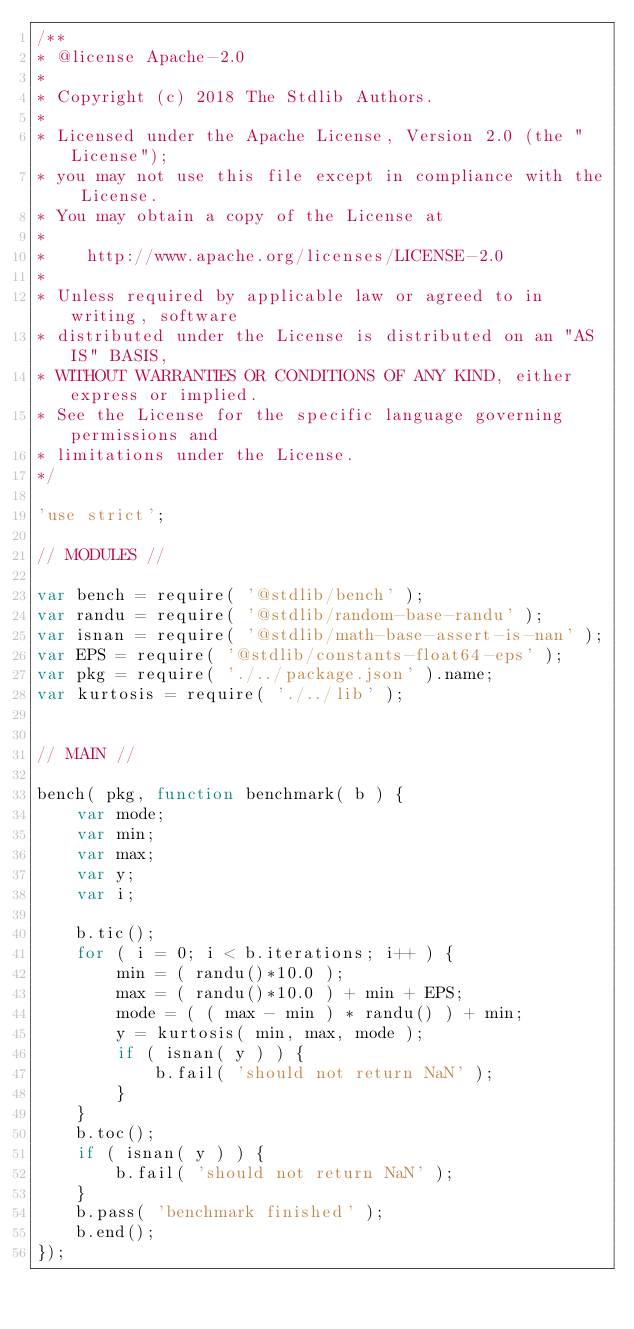<code> <loc_0><loc_0><loc_500><loc_500><_JavaScript_>/**
* @license Apache-2.0
*
* Copyright (c) 2018 The Stdlib Authors.
*
* Licensed under the Apache License, Version 2.0 (the "License");
* you may not use this file except in compliance with the License.
* You may obtain a copy of the License at
*
*    http://www.apache.org/licenses/LICENSE-2.0
*
* Unless required by applicable law or agreed to in writing, software
* distributed under the License is distributed on an "AS IS" BASIS,
* WITHOUT WARRANTIES OR CONDITIONS OF ANY KIND, either express or implied.
* See the License for the specific language governing permissions and
* limitations under the License.
*/

'use strict';

// MODULES //

var bench = require( '@stdlib/bench' );
var randu = require( '@stdlib/random-base-randu' );
var isnan = require( '@stdlib/math-base-assert-is-nan' );
var EPS = require( '@stdlib/constants-float64-eps' );
var pkg = require( './../package.json' ).name;
var kurtosis = require( './../lib' );


// MAIN //

bench( pkg, function benchmark( b ) {
	var mode;
	var min;
	var max;
	var y;
	var i;

	b.tic();
	for ( i = 0; i < b.iterations; i++ ) {
		min = ( randu()*10.0 );
		max = ( randu()*10.0 ) + min + EPS;
		mode = ( ( max - min ) * randu() ) + min;
		y = kurtosis( min, max, mode );
		if ( isnan( y ) ) {
			b.fail( 'should not return NaN' );
		}
	}
	b.toc();
	if ( isnan( y ) ) {
		b.fail( 'should not return NaN' );
	}
	b.pass( 'benchmark finished' );
	b.end();
});
</code> 